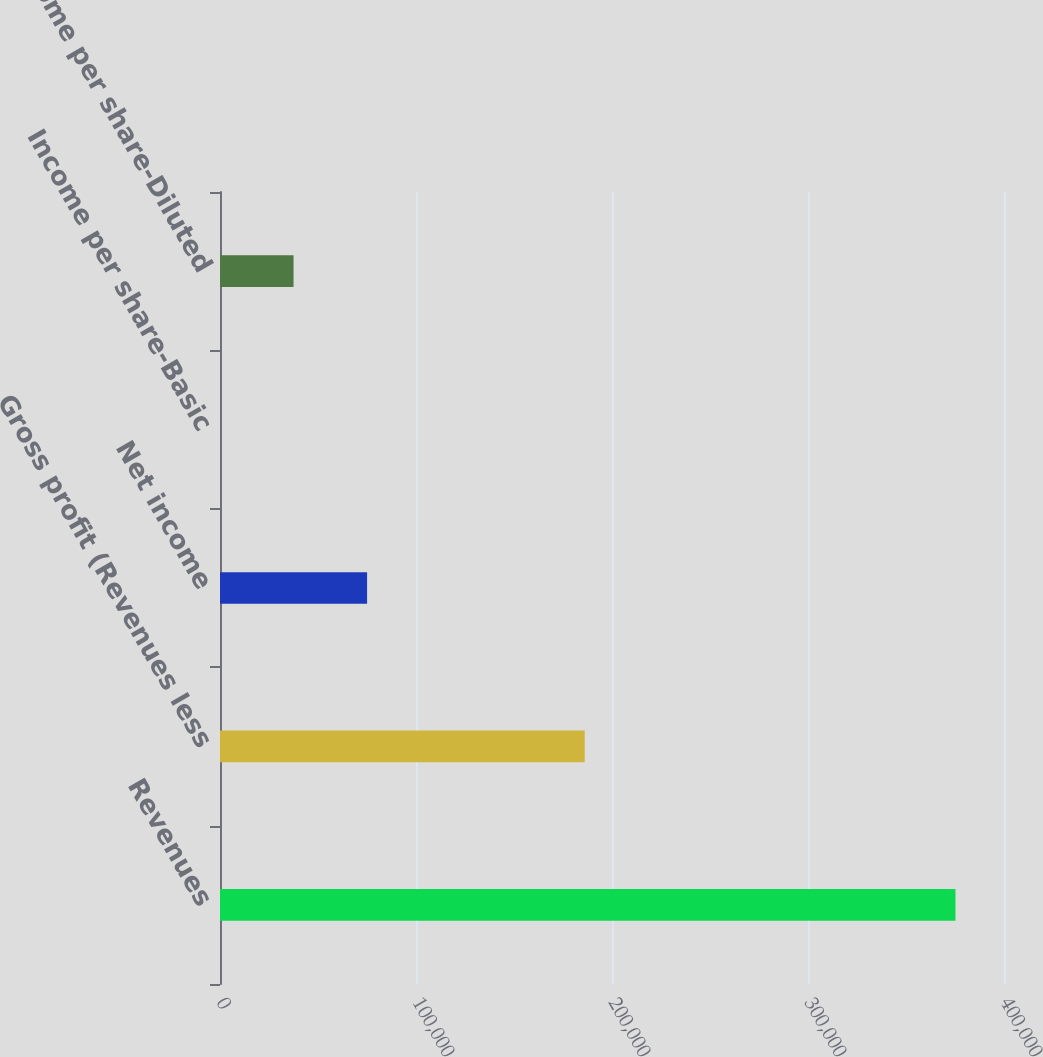Convert chart. <chart><loc_0><loc_0><loc_500><loc_500><bar_chart><fcel>Revenues<fcel>Gross profit (Revenues less<fcel>Net income<fcel>Income per share-Basic<fcel>Income per share-Diluted<nl><fcel>375247<fcel>186084<fcel>75049.5<fcel>0.18<fcel>37524.9<nl></chart> 